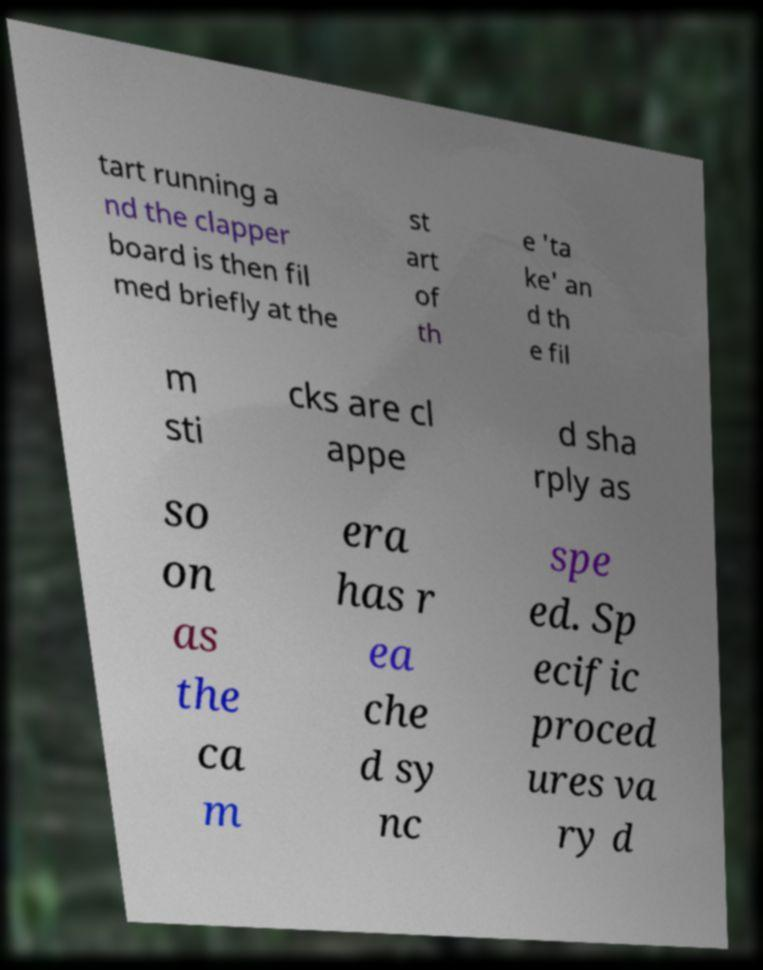What messages or text are displayed in this image? I need them in a readable, typed format. tart running a nd the clapper board is then fil med briefly at the st art of th e 'ta ke' an d th e fil m sti cks are cl appe d sha rply as so on as the ca m era has r ea che d sy nc spe ed. Sp ecific proced ures va ry d 